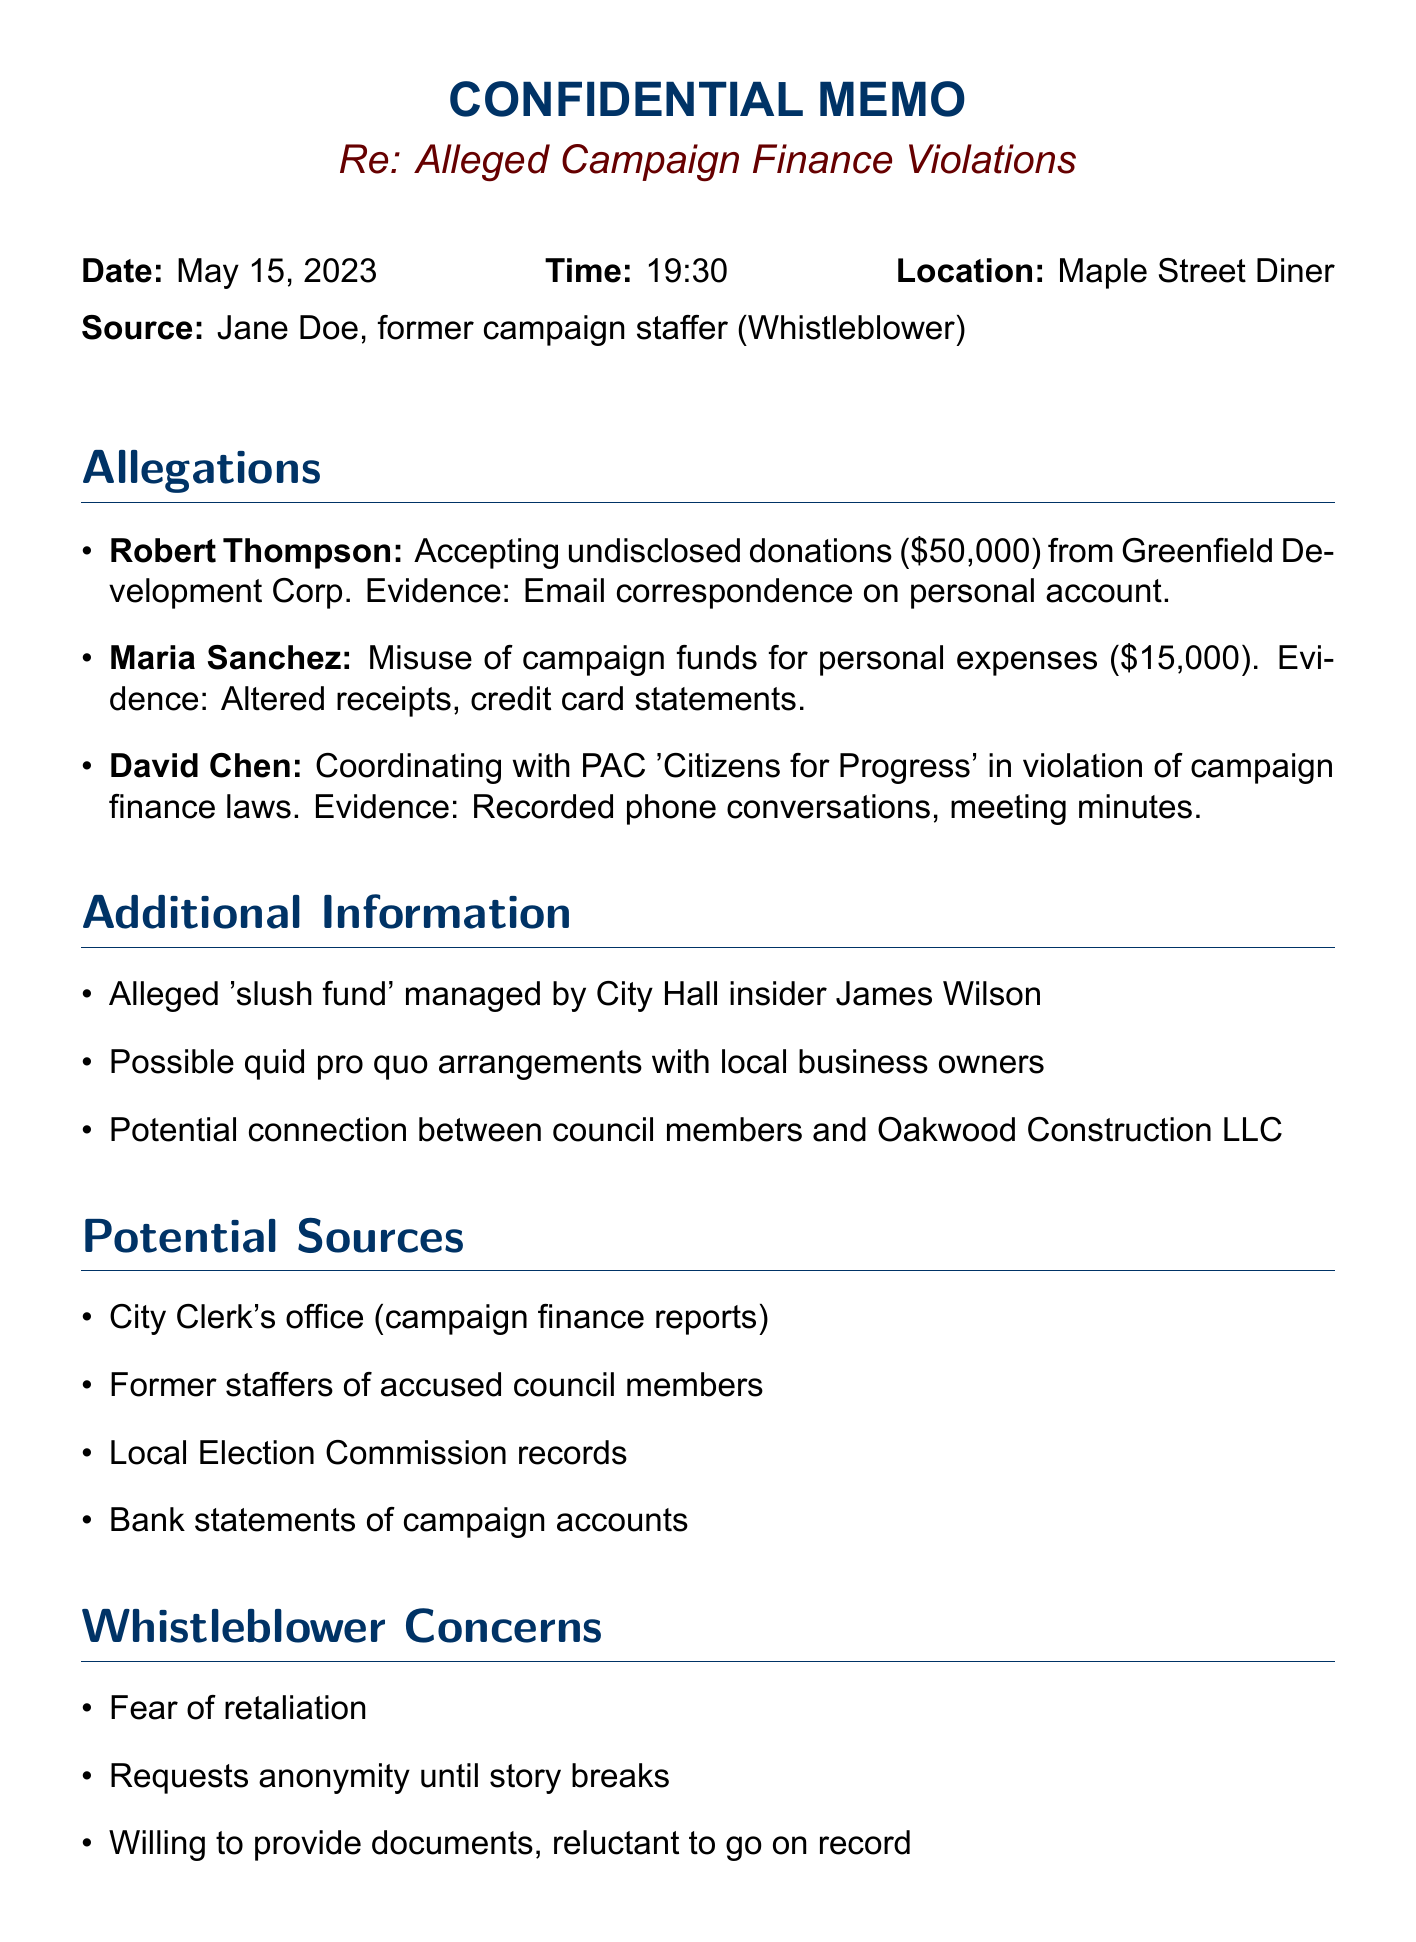What is the date of the meeting? The date of the meeting is specified in the document under meeting details.
Answer: May 15, 2023 Who is the whistleblower? The whistleblower's name is mentioned at the beginning of the document.
Answer: Jane Doe How much did Robert Thompson allegedly accept in undisclosed donations? The amount was provided as part of the allegations against Robert Thompson.
Answer: $50,000 What are the potential sources for verification mentioned in the document? The potential sources section lists places to seek additional information.
Answer: City Clerk's office for campaign finance reports Who managed the alleged 'slush fund'? The document notes a specific individual connected to the alleged slush fund.
Answer: James Wilson What is one concern the whistleblower has? The whistleblower's concerns are listed individually in the document.
Answer: Fear of retaliation Which city council member is accused of misusing campaign funds? The specific council member that is mentioned in the allegations is outlined in the document.
Answer: Maria Sanchez What should be requested from the accused council members as a next step? The next steps section indicates actions to be taken regarding the accused council members.
Answer: Official comment What is the location of the meeting? The location is specified in the header of the document.
Answer: Maple Street Diner 